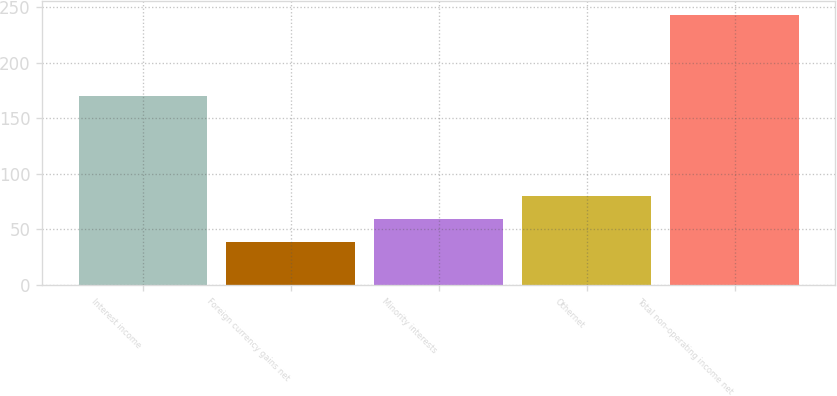Convert chart to OTSL. <chart><loc_0><loc_0><loc_500><loc_500><bar_chart><fcel>Interest income<fcel>Foreign currency gains net<fcel>Minority interests<fcel>Othernet<fcel>Total non-operating income net<nl><fcel>170<fcel>39<fcel>59.4<fcel>79.8<fcel>243<nl></chart> 